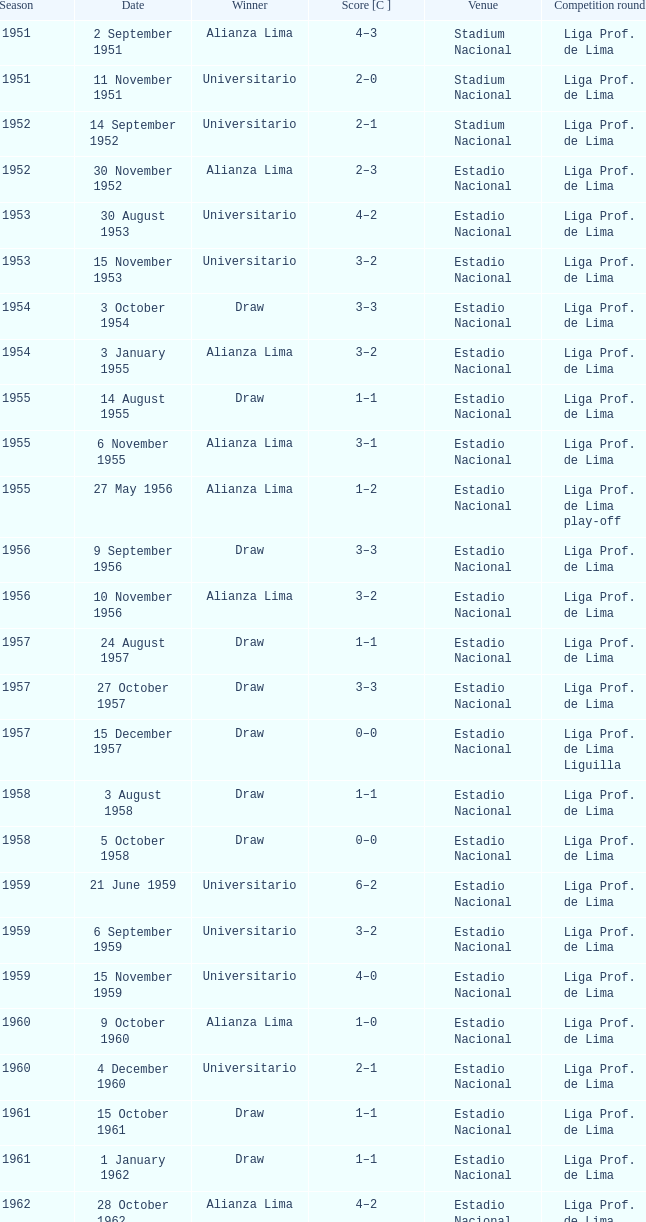Which location hosted an event on november 17, 1963? Estadio Nacional. 